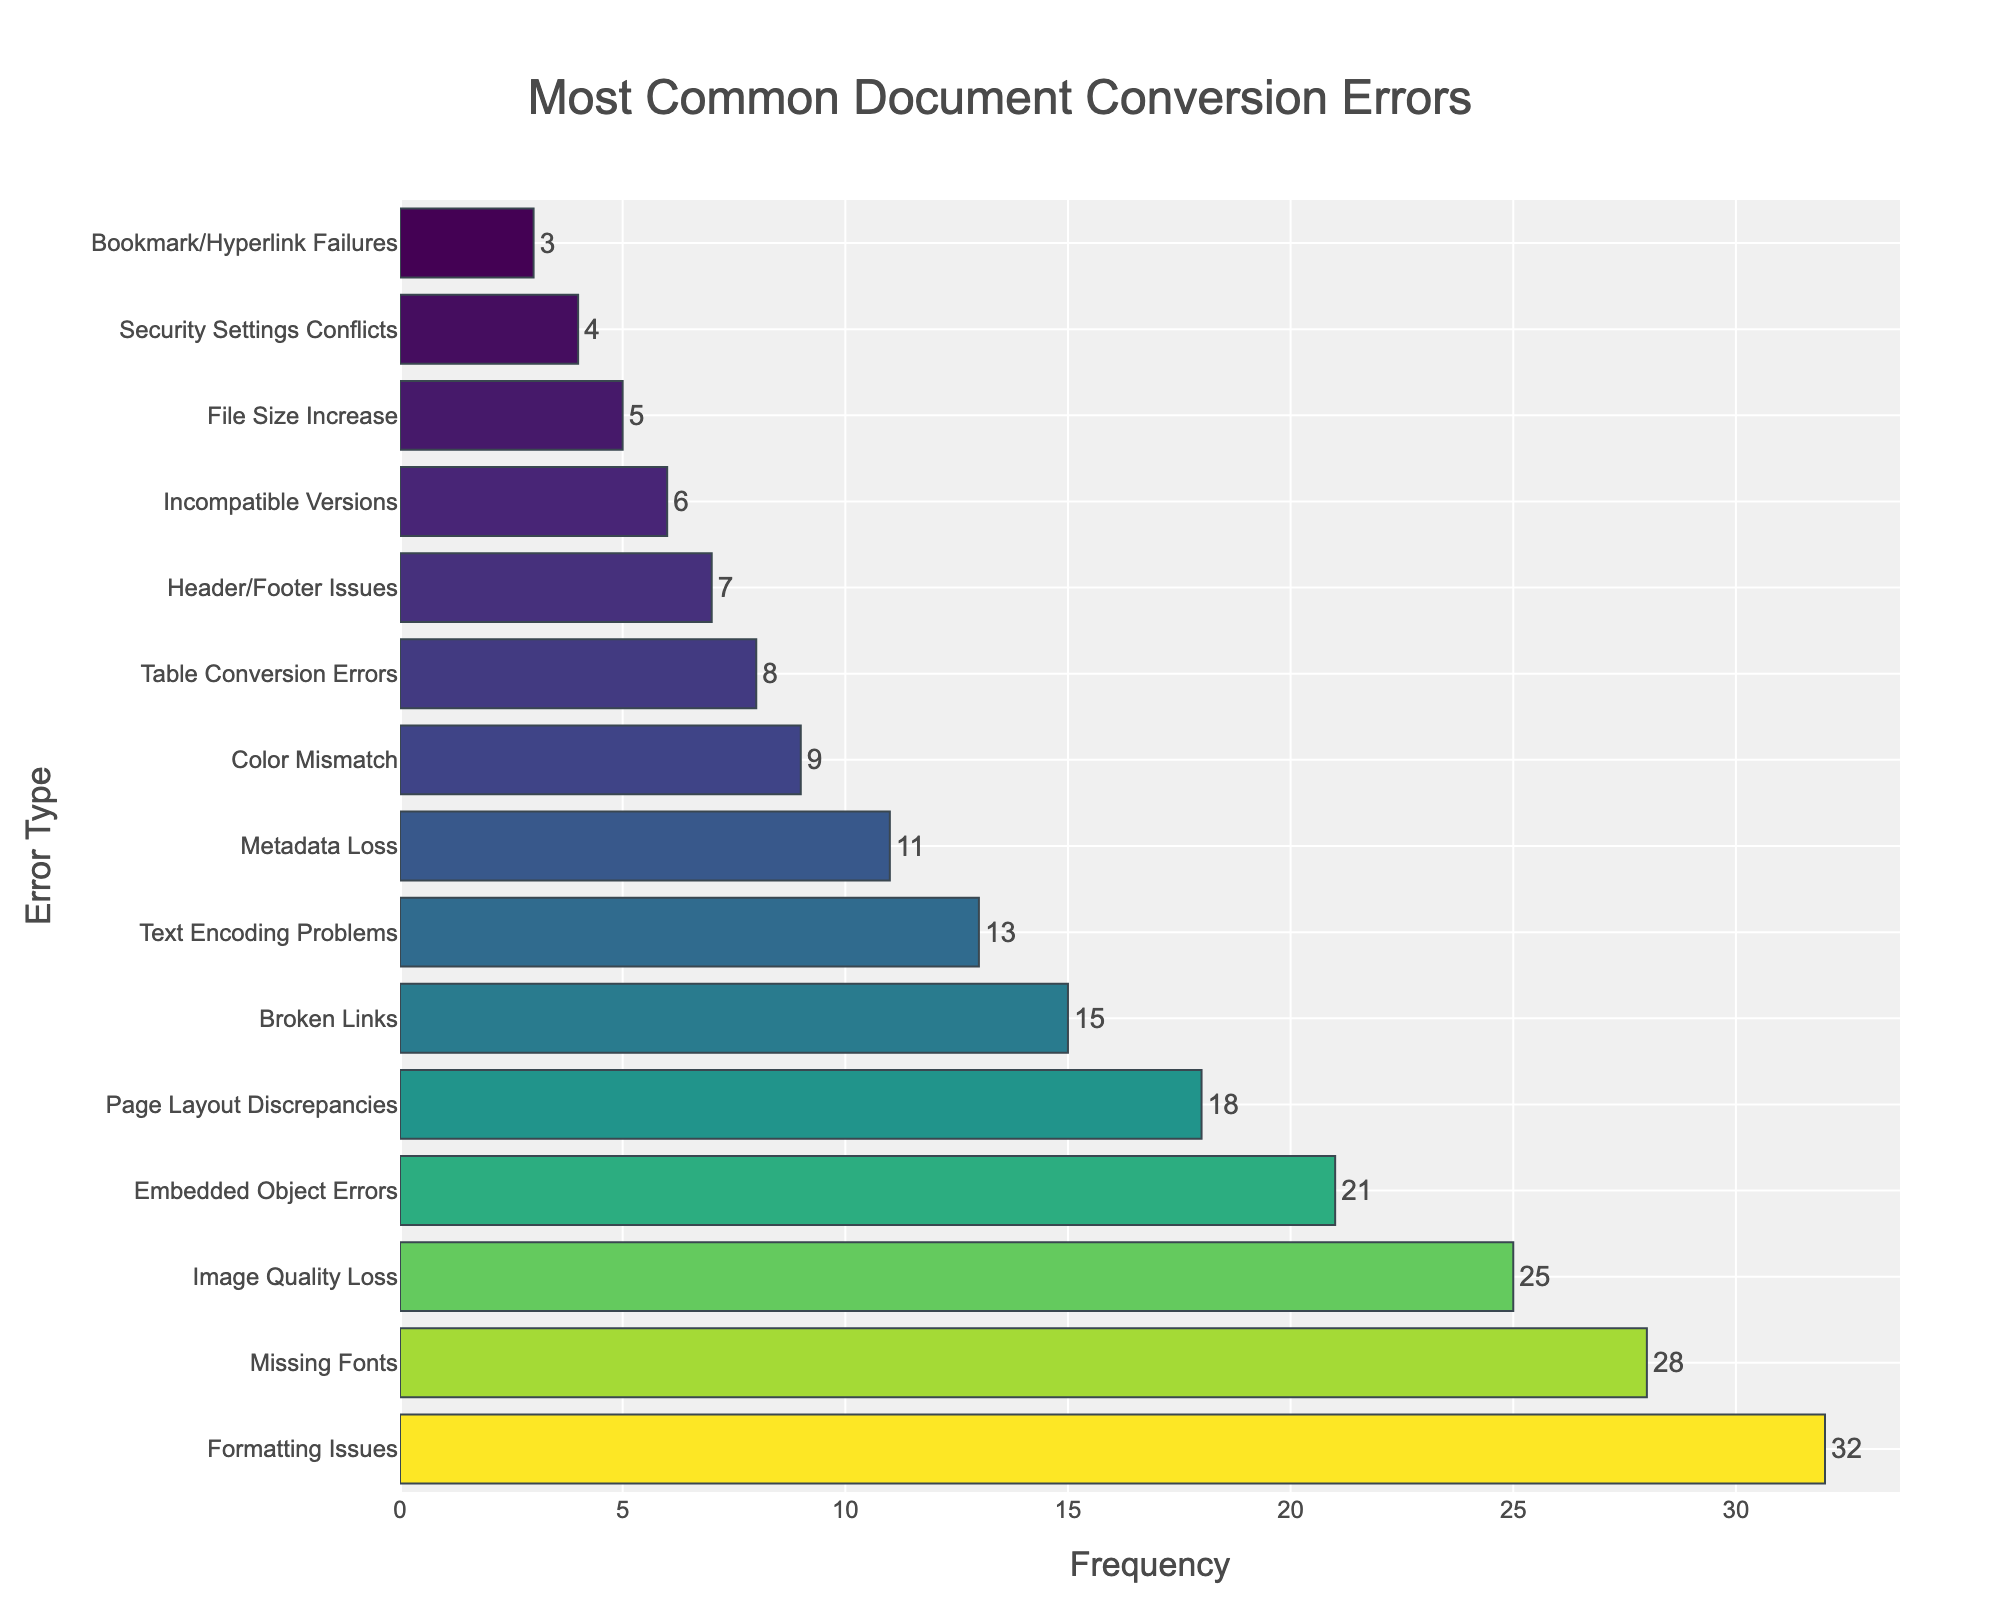what is the most common document conversion error? The figure has 'Most Common Document Conversion Errors' as its title. The longest bar in the bar chart represents the most frequent error. The longest bar in the figure corresponds to 'Formatting Issues' with a frequency of 32.
Answer: Formatting Issues how many more times do Formatting Issues occur compared to Metadata Loss? To find out how many more times Formatting Issues occur compared to Metadata Loss, we need to subtract the frequency of Metadata Loss from the frequency of Formatting Issues. From the figure, Formatting Issues occur 32 times and Metadata Loss occurs 11 times. The difference is 32 - 11 = 21.
Answer: 21 which error has a lower frequency: Image Quality Loss or Broken Links? By comparing the length of the bars for 'Image Quality Loss' and 'Broken Links' in the bar chart, we see that 'Broken Links' has a shorter bar than 'Image Quality Loss,' indicating that it occurs less frequently. Image Quality Loss has a frequency of 25, whereas Broken Links have a frequency of 15.
Answer: Broken Links are Text Encoding Problems more common than Page Layout Discrepancies? To determine this, we compare the lengths of the bars for 'Text Encoding Problems' and 'Page Layout Discrepancies'. The bar for 'Page Layout Discrepancies' is longer than the bar for 'Text Encoding Problems'. Page Layout Discrepancies have a frequency of 18 while Text Encoding Problems have a frequency of 13, indicating that Page Layout Discrepancies are more common.
Answer: No how many times do Security Settings Conflicts and Incompatible Versions occur together? To find the combined frequency, add the frequency of Security Settings Conflicts and the frequency of Incompatible Versions. From the figure, Security Settings Conflicts occur 4 times and Incompatible Versions occur 6 times. The combined frequency is 4 + 6 = 10.
Answer: 10 is the frequency of Bookmark/Hyperlink Failures less than the frequency of Incompatible Versions? By looking at the lengths of the bars for 'Bookmark/Hyperlink Failures' and 'Incompatible Versions', we see that the bar for 'Bookmark/Hyperlink Failures' is shorter. Bookmark/Hyperlink Failures have a frequency of 3 while Incompatible Versions have a frequency of 6, indicating that Bookmark/Hyperlink Failures are less frequent.
Answer: Yes which errors have a frequency equal to or less than Table Conversion Errors? To answer this, look for bars that are as short as or shorter than the 'Table Conversion Errors' bar, which has a frequency of 8. Errors that fit this criterion are 'Header/Footer Issues' (7), 'Incompatible Versions' (6), 'File Size Increase' (5), 'Security Settings Conflicts' (4), and 'Bookmark/Hyperlink Failures' (3).
Answer: Header/Footer Issues, Incompatible Versions, File Size Increase, Security Settings Conflicts, Bookmark/Hyperlink Failures what is the total frequency of the top three most common errors? Identify and sum the frequencies of the top three most common errors from the figure. The top three errors are 'Formatting Issues' (32), 'Missing Fonts' (28), and 'Image Quality Loss' (25). The total frequency is 32 + 28 + 25 = 85.
Answer: 85 how does the frequency of Broken Links compare to the combined frequency of Metadata Loss and Table Conversion Errors? First, sum the frequencies of Metadata Loss (11) and Table Conversion Errors (8), which gives us 11 + 8 = 19. Comparatively, Broken Links have a frequency of 15. Since 15 is less than 19, Broken Links occur less frequently than the combined frequency of Metadata Loss and Table Conversion Errors.
Answer: Less 